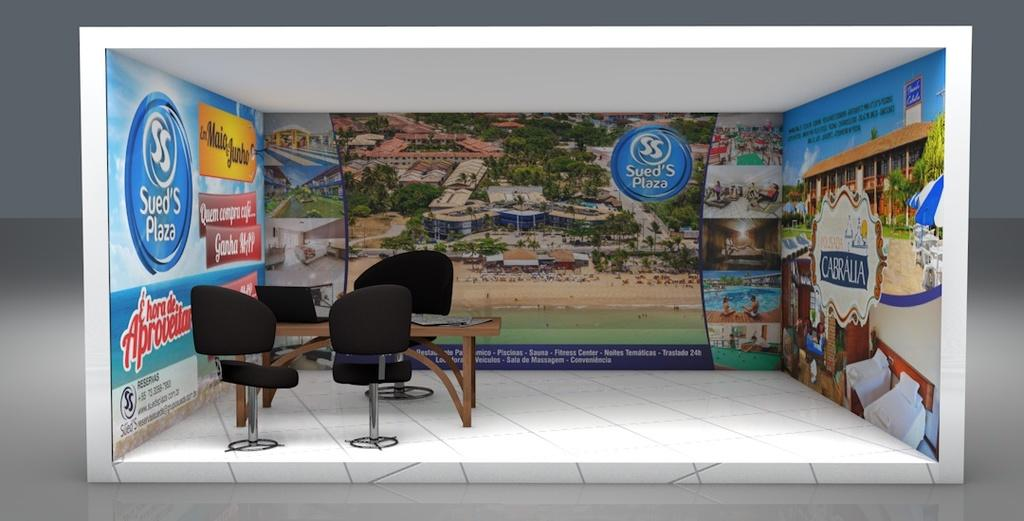What can be seen in the background of the image? There is a banner in the background of the image. What type of furniture is present in the image? There are chairs and a table in the image. Where is the electronic device located in the image? The electronic device is on the left side of the image. Can you see a rake being used in the image? There is no rake present in the image. What shape is the cactus in the image? There is no cactus present in the image. 